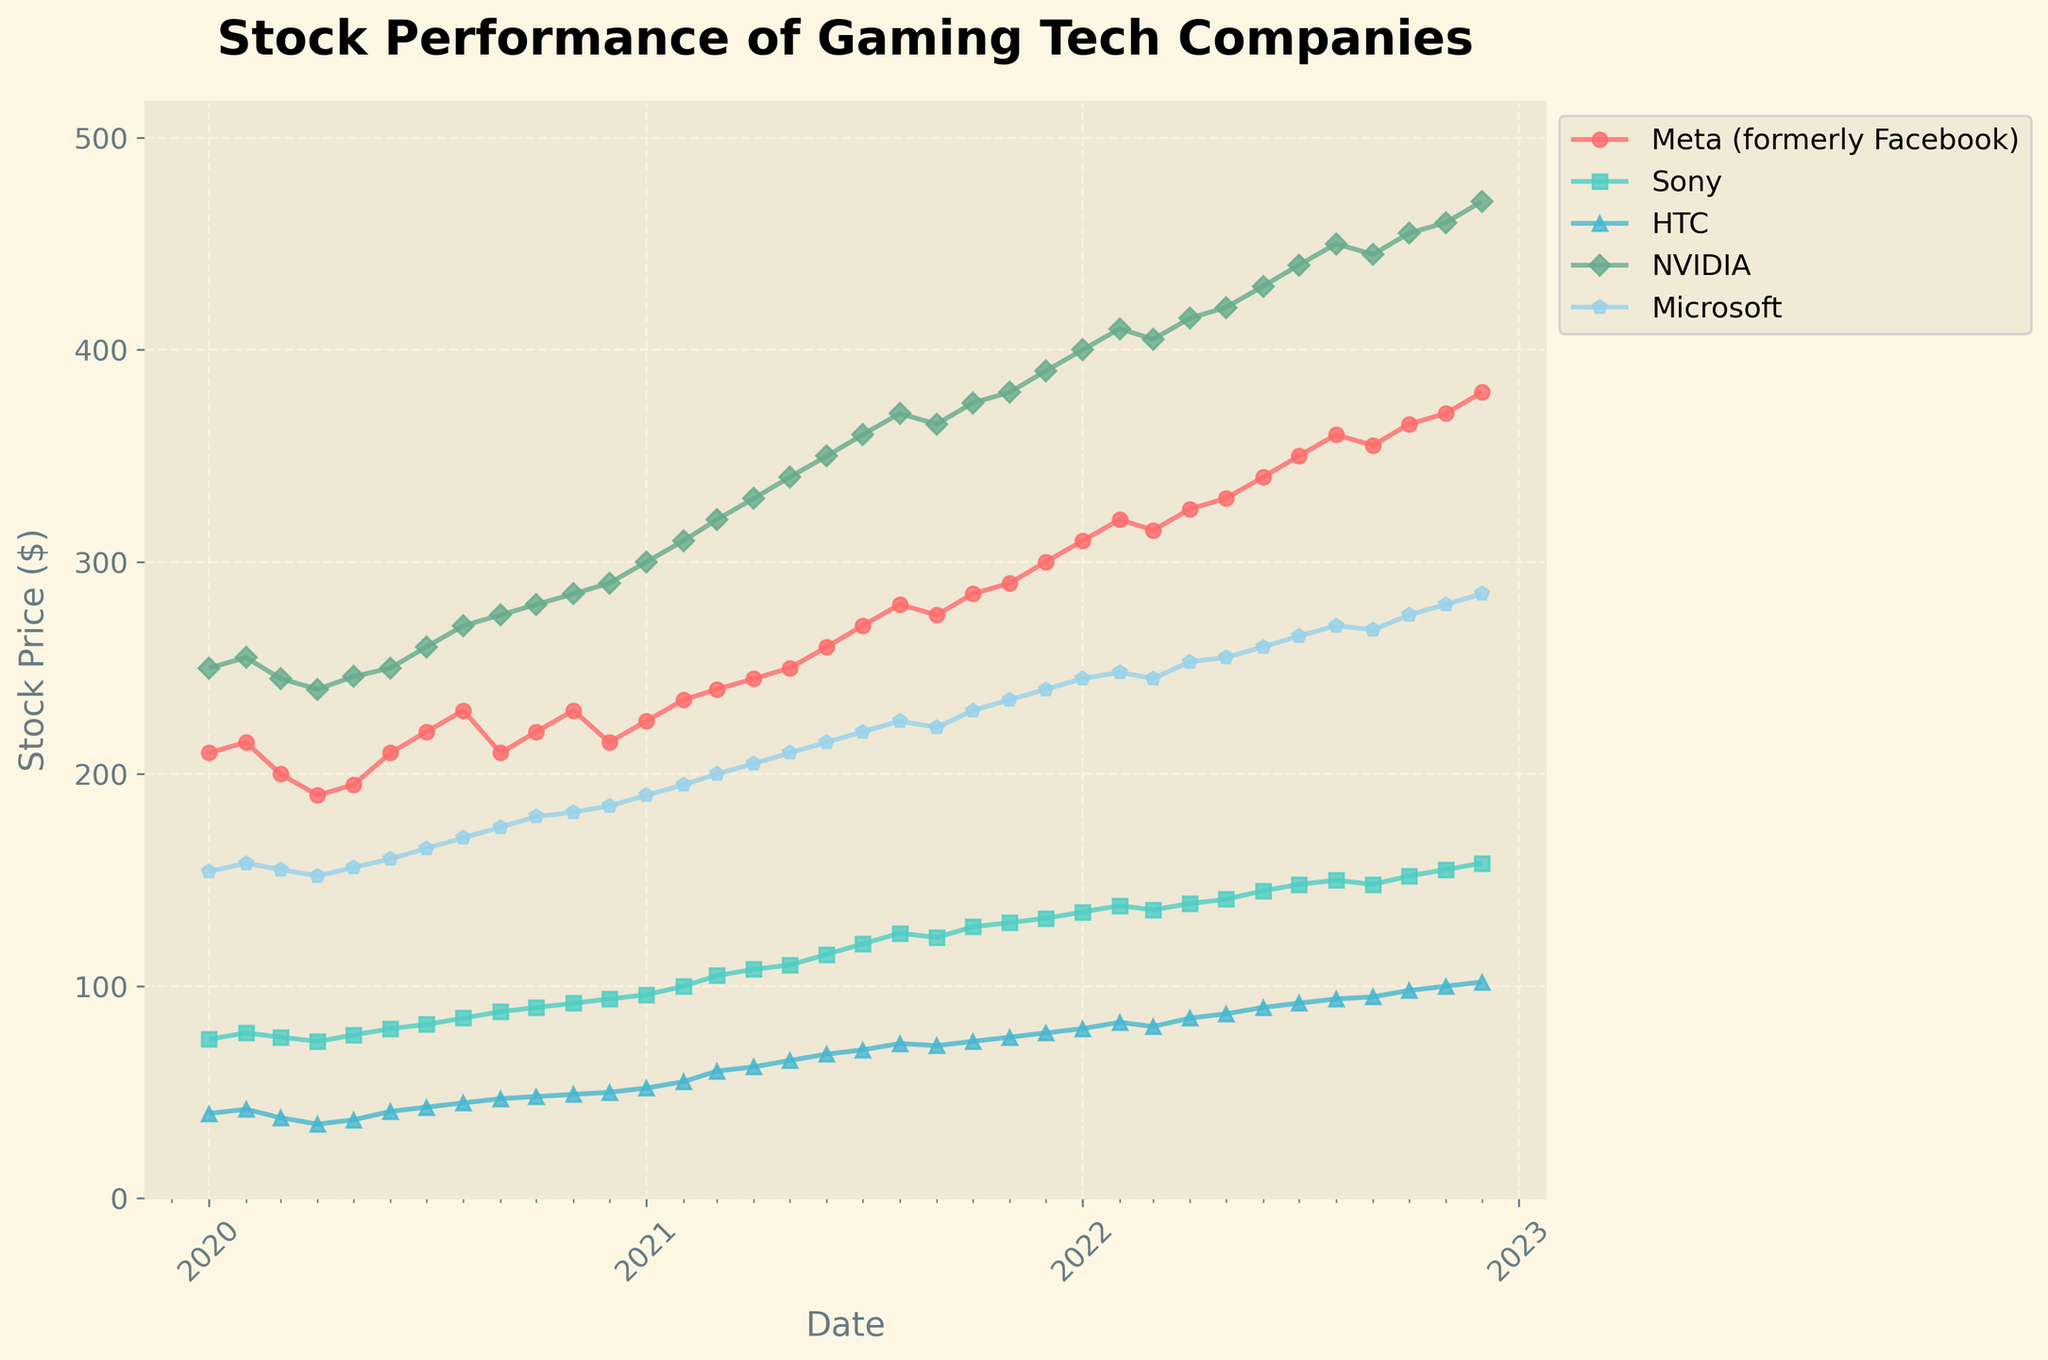What is the title of the plot? The title of the plot is located at the top and is usually the largest text among the elements.
Answer: Stock Performance of Gaming Tech Companies Which company had the highest stock price at the end of 2022? Look at the last data point on the x-axis (Date) in 2022 and check which company's stock price is the highest on the y-axis.
Answer: NVIDIA Between Aug 2021 and Dec 2021, which company showed the most significant stock price increase? Compare the stock prices in Aug 2021 and Dec 2021 for each company and note the differences.
Answer: NVIDIA What is the average stock price of Sony in 2021? Identify all the data points for Sony in the year 2021, sum them up, and divide by the number of data points (12 months).
Answer: 111.17 How did HTC's stock price change from Jan 2020 to Dec 2022? Look at the stock prices for HTC in Jan 2020 and Dec 2022, and calculate the difference.
Answer: Increased by 62 Which two companies had the closest stock prices in Nov 2022? Compare all stock prices in Nov 2022 and find the two with the smallest difference.
Answer: Sony and HTC During which month and year did Meta (formerly Facebook) show the steepest increase? Look for the largest upward slope in the plot line for Meta and identify the corresponding month and year.
Answer: Feb 2021 From Mar 2022 to Sep 2022, which company experienced a consistent increase each month? Check each company's month-to-month stock prices between Mar 2022 and Sep 2022 to find the one that increased consistently.
Answer: NVIDIA What was the stock price of Microsoft in Nov 2022? Find the data point for Microsoft in Nov 2022 and read off the stock price.
Answer: 280 